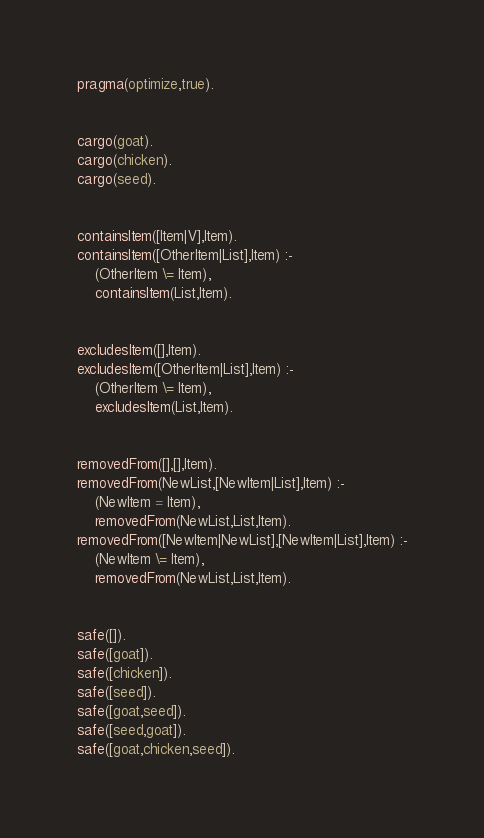Convert code to text. <code><loc_0><loc_0><loc_500><loc_500><_Prolog_>pragma(optimize,true).


cargo(goat).
cargo(chicken).
cargo(seed).


containsItem([Item|V],Item).
containsItem([OtherItem|List],Item) :-
    (OtherItem \= Item),
    containsItem(List,Item).


excludesItem([],Item).
excludesItem([OtherItem|List],Item) :-
    (OtherItem \= Item),
    excludesItem(List,Item).


removedFrom([],[],Item).
removedFrom(NewList,[NewItem|List],Item) :-
    (NewItem = Item),
    removedFrom(NewList,List,Item).
removedFrom([NewItem|NewList],[NewItem|List],Item) :-
    (NewItem \= Item),
    removedFrom(NewList,List,Item).


safe([]).
safe([goat]).
safe([chicken]).
safe([seed]).
safe([goat,seed]).
safe([seed,goat]).
safe([goat,chicken,seed]).</code> 